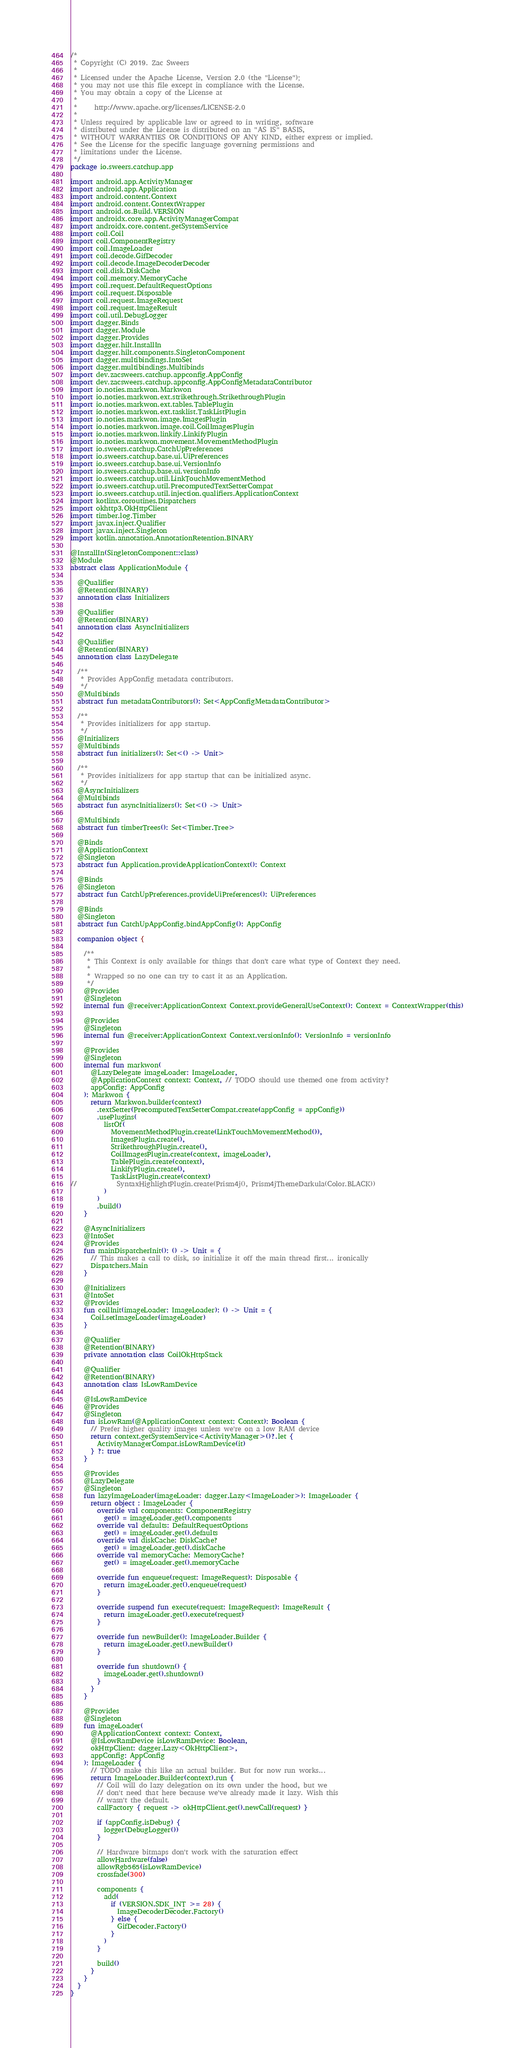Convert code to text. <code><loc_0><loc_0><loc_500><loc_500><_Kotlin_>/*
 * Copyright (C) 2019. Zac Sweers
 *
 * Licensed under the Apache License, Version 2.0 (the "License");
 * you may not use this file except in compliance with the License.
 * You may obtain a copy of the License at
 *
 *     http://www.apache.org/licenses/LICENSE-2.0
 *
 * Unless required by applicable law or agreed to in writing, software
 * distributed under the License is distributed on an "AS IS" BASIS,
 * WITHOUT WARRANTIES OR CONDITIONS OF ANY KIND, either express or implied.
 * See the License for the specific language governing permissions and
 * limitations under the License.
 */
package io.sweers.catchup.app

import android.app.ActivityManager
import android.app.Application
import android.content.Context
import android.content.ContextWrapper
import android.os.Build.VERSION
import androidx.core.app.ActivityManagerCompat
import androidx.core.content.getSystemService
import coil.Coil
import coil.ComponentRegistry
import coil.ImageLoader
import coil.decode.GifDecoder
import coil.decode.ImageDecoderDecoder
import coil.disk.DiskCache
import coil.memory.MemoryCache
import coil.request.DefaultRequestOptions
import coil.request.Disposable
import coil.request.ImageRequest
import coil.request.ImageResult
import coil.util.DebugLogger
import dagger.Binds
import dagger.Module
import dagger.Provides
import dagger.hilt.InstallIn
import dagger.hilt.components.SingletonComponent
import dagger.multibindings.IntoSet
import dagger.multibindings.Multibinds
import dev.zacsweers.catchup.appconfig.AppConfig
import dev.zacsweers.catchup.appconfig.AppConfigMetadataContributor
import io.noties.markwon.Markwon
import io.noties.markwon.ext.strikethrough.StrikethroughPlugin
import io.noties.markwon.ext.tables.TablePlugin
import io.noties.markwon.ext.tasklist.TaskListPlugin
import io.noties.markwon.image.ImagesPlugin
import io.noties.markwon.image.coil.CoilImagesPlugin
import io.noties.markwon.linkify.LinkifyPlugin
import io.noties.markwon.movement.MovementMethodPlugin
import io.sweers.catchup.CatchUpPreferences
import io.sweers.catchup.base.ui.UiPreferences
import io.sweers.catchup.base.ui.VersionInfo
import io.sweers.catchup.base.ui.versionInfo
import io.sweers.catchup.util.LinkTouchMovementMethod
import io.sweers.catchup.util.PrecomputedTextSetterCompat
import io.sweers.catchup.util.injection.qualifiers.ApplicationContext
import kotlinx.coroutines.Dispatchers
import okhttp3.OkHttpClient
import timber.log.Timber
import javax.inject.Qualifier
import javax.inject.Singleton
import kotlin.annotation.AnnotationRetention.BINARY

@InstallIn(SingletonComponent::class)
@Module
abstract class ApplicationModule {

  @Qualifier
  @Retention(BINARY)
  annotation class Initializers

  @Qualifier
  @Retention(BINARY)
  annotation class AsyncInitializers

  @Qualifier
  @Retention(BINARY)
  annotation class LazyDelegate

  /**
   * Provides AppConfig metadata contributors.
   */
  @Multibinds
  abstract fun metadataContributors(): Set<AppConfigMetadataContributor>

  /**
   * Provides initializers for app startup.
   */
  @Initializers
  @Multibinds
  abstract fun initializers(): Set<() -> Unit>

  /**
   * Provides initializers for app startup that can be initialized async.
   */
  @AsyncInitializers
  @Multibinds
  abstract fun asyncInitializers(): Set<() -> Unit>

  @Multibinds
  abstract fun timberTrees(): Set<Timber.Tree>

  @Binds
  @ApplicationContext
  @Singleton
  abstract fun Application.provideApplicationContext(): Context

  @Binds
  @Singleton
  abstract fun CatchUpPreferences.provideUiPreferences(): UiPreferences

  @Binds
  @Singleton
  abstract fun CatchUpAppConfig.bindAppConfig(): AppConfig

  companion object {

    /**
     * This Context is only available for things that don't care what type of Context they need.
     *
     * Wrapped so no one can try to cast it as an Application.
     */
    @Provides
    @Singleton
    internal fun @receiver:ApplicationContext Context.provideGeneralUseContext(): Context = ContextWrapper(this)

    @Provides
    @Singleton
    internal fun @receiver:ApplicationContext Context.versionInfo(): VersionInfo = versionInfo

    @Provides
    @Singleton
    internal fun markwon(
      @LazyDelegate imageLoader: ImageLoader,
      @ApplicationContext context: Context, // TODO should use themed one from activity?
      appConfig: AppConfig
    ): Markwon {
      return Markwon.builder(context)
        .textSetter(PrecomputedTextSetterCompat.create(appConfig = appConfig))
        .usePlugins(
          listOf(
            MovementMethodPlugin.create(LinkTouchMovementMethod()),
            ImagesPlugin.create(),
            StrikethroughPlugin.create(),
            CoilImagesPlugin.create(context, imageLoader),
            TablePlugin.create(context),
            LinkifyPlugin.create(),
            TaskListPlugin.create(context)
//            SyntaxHighlightPlugin.create(Prism4j(), Prism4jThemeDarkula(Color.BLACK))
          )
        )
        .build()
    }

    @AsyncInitializers
    @IntoSet
    @Provides
    fun mainDispatcherInit(): () -> Unit = {
      // This makes a call to disk, so initialize it off the main thread first... ironically
      Dispatchers.Main
    }

    @Initializers
    @IntoSet
    @Provides
    fun coilInit(imageLoader: ImageLoader): () -> Unit = {
      Coil.setImageLoader(imageLoader)
    }

    @Qualifier
    @Retention(BINARY)
    private annotation class CoilOkHttpStack

    @Qualifier
    @Retention(BINARY)
    annotation class IsLowRamDevice

    @IsLowRamDevice
    @Provides
    @Singleton
    fun isLowRam(@ApplicationContext context: Context): Boolean {
      // Prefer higher quality images unless we're on a low RAM device
      return context.getSystemService<ActivityManager>()?.let {
        ActivityManagerCompat.isLowRamDevice(it)
      } ?: true
    }

    @Provides
    @LazyDelegate
    @Singleton
    fun lazyImageLoader(imageLoader: dagger.Lazy<ImageLoader>): ImageLoader {
      return object : ImageLoader {
        override val components: ComponentRegistry
          get() = imageLoader.get().components
        override val defaults: DefaultRequestOptions
          get() = imageLoader.get().defaults
        override val diskCache: DiskCache?
          get() = imageLoader.get().diskCache
        override val memoryCache: MemoryCache?
          get() = imageLoader.get().memoryCache

        override fun enqueue(request: ImageRequest): Disposable {
          return imageLoader.get().enqueue(request)
        }

        override suspend fun execute(request: ImageRequest): ImageResult {
          return imageLoader.get().execute(request)
        }

        override fun newBuilder(): ImageLoader.Builder {
          return imageLoader.get().newBuilder()
        }

        override fun shutdown() {
          imageLoader.get().shutdown()
        }
      }
    }

    @Provides
    @Singleton
    fun imageLoader(
      @ApplicationContext context: Context,
      @IsLowRamDevice isLowRamDevice: Boolean,
      okHttpClient: dagger.Lazy<OkHttpClient>,
      appConfig: AppConfig
    ): ImageLoader {
      // TODO make this like an actual builder. But for now run works...
      return ImageLoader.Builder(context).run {
        // Coil will do lazy delegation on its own under the hood, but we
        // don't need that here because we've already made it lazy. Wish this
        // wasn't the default.
        callFactory { request -> okHttpClient.get().newCall(request) }

        if (appConfig.isDebug) {
          logger(DebugLogger())
        }

        // Hardware bitmaps don't work with the saturation effect
        allowHardware(false)
        allowRgb565(isLowRamDevice)
        crossfade(300)

        components {
          add(
            if (VERSION.SDK_INT >= 28) {
              ImageDecoderDecoder.Factory()
            } else {
              GifDecoder.Factory()
            }
          )
        }

        build()
      }
    }
  }
}
</code> 